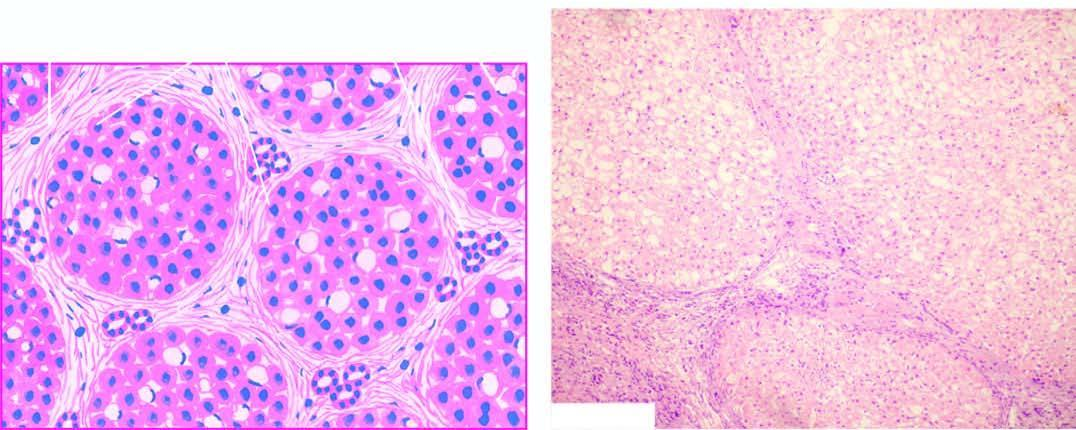s there minimal inflammation and some reactive bile duct proliferation in the septa?
Answer the question using a single word or phrase. Yes 